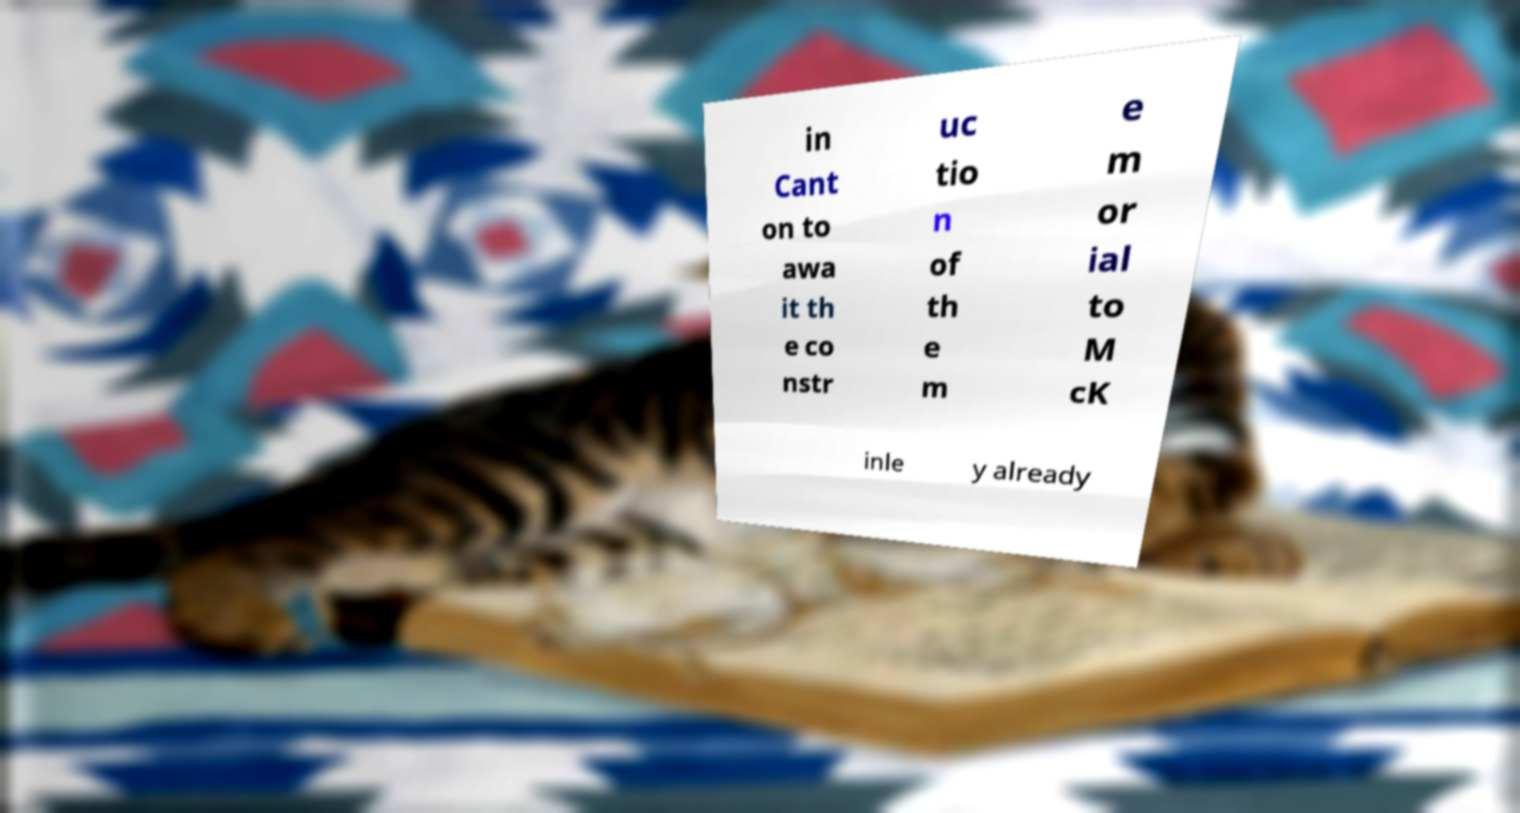Can you accurately transcribe the text from the provided image for me? in Cant on to awa it th e co nstr uc tio n of th e m e m or ial to M cK inle y already 